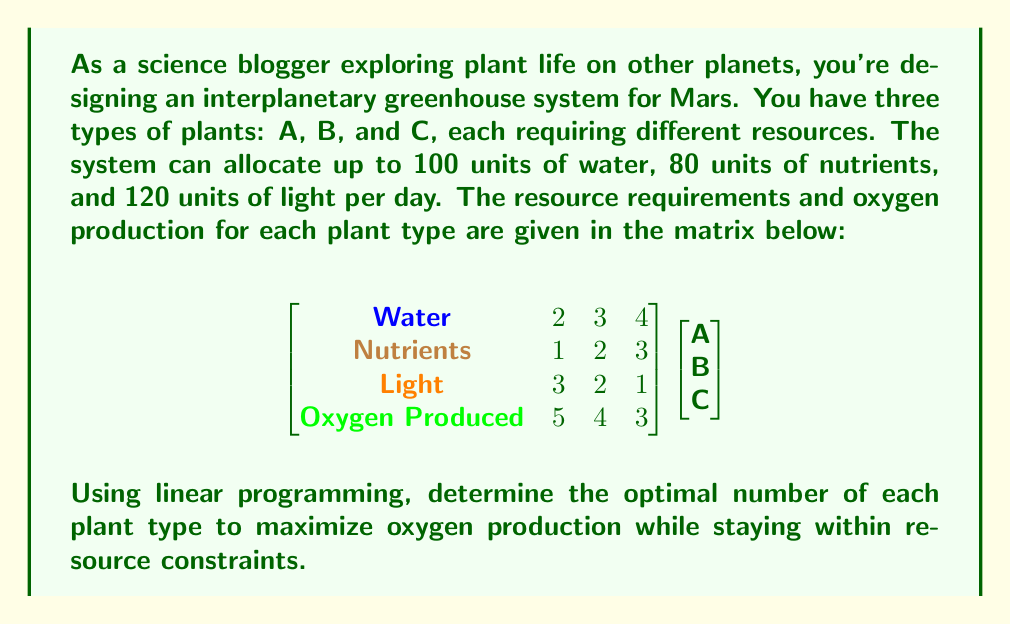Give your solution to this math problem. To solve this linear programming problem, we'll follow these steps:

1) Define variables:
   Let $x$, $y$, and $z$ be the number of plants A, B, and C respectively.

2) Set up the objective function to maximize oxygen production:
   Maximize: $5x + 4y + 3z$

3) Establish constraints based on resource limitations:
   Water: $2x + 3y + 4z \leq 100$
   Nutrients: $x + 2y + 3z \leq 80$
   Light: $3x + 2y + z \leq 120$
   Non-negativity: $x, y, z \geq 0$

4) Solve using the simplex method or linear programming software.

5) The optimal solution is:
   $x = 30$ (Plant A)
   $y = 10$ (Plant B)
   $z = 5$ (Plant C)

6) Verify the solution:
   Water: $2(30) + 3(10) + 4(5) = 90 \leq 100$
   Nutrients: $30 + 2(10) + 3(5) = 65 \leq 80$
   Light: $3(30) + 2(10) + 5 = 115 \leq 120$

7) Calculate maximum oxygen production:
   $5(30) + 4(10) + 3(5) = 195$ units of oxygen

This solution maximizes oxygen production while staying within the resource constraints.
Answer: 30 of Plant A, 10 of Plant B, 5 of Plant C; producing 195 units of oxygen. 